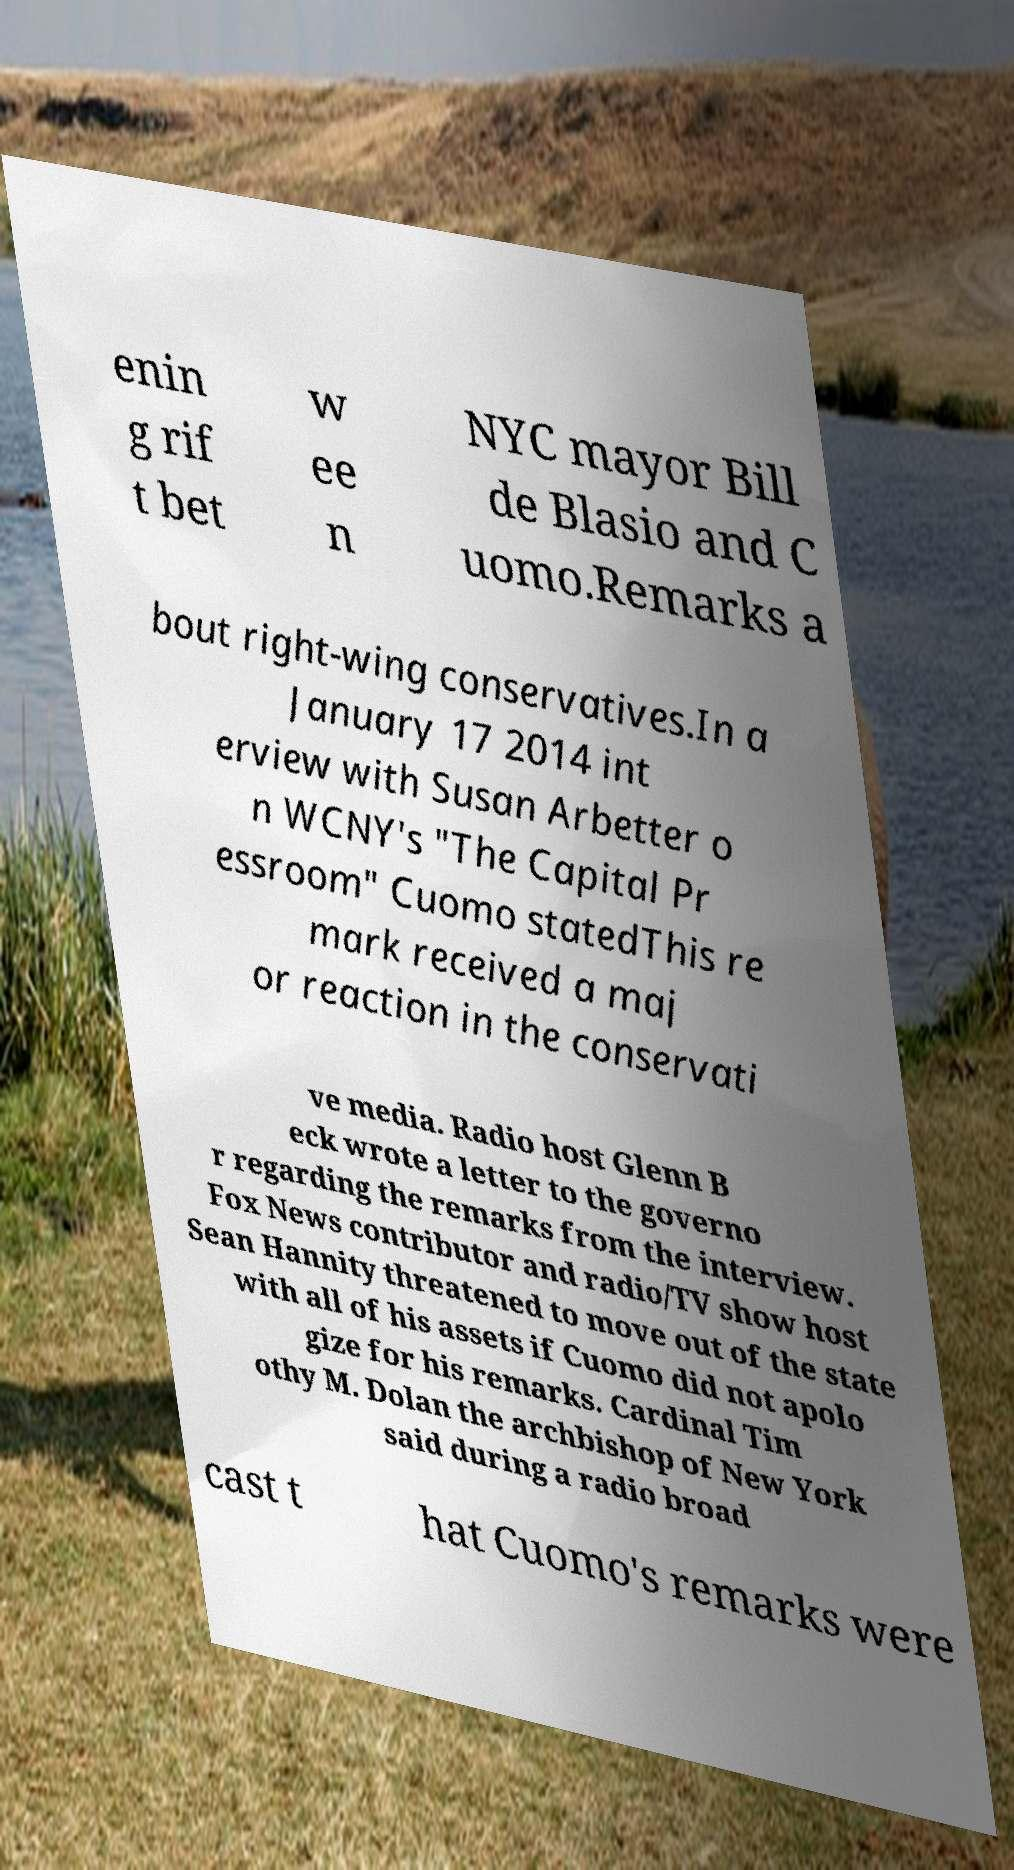For documentation purposes, I need the text within this image transcribed. Could you provide that? enin g rif t bet w ee n NYC mayor Bill de Blasio and C uomo.Remarks a bout right-wing conservatives.In a January 17 2014 int erview with Susan Arbetter o n WCNY's "The Capital Pr essroom" Cuomo statedThis re mark received a maj or reaction in the conservati ve media. Radio host Glenn B eck wrote a letter to the governo r regarding the remarks from the interview. Fox News contributor and radio/TV show host Sean Hannity threatened to move out of the state with all of his assets if Cuomo did not apolo gize for his remarks. Cardinal Tim othy M. Dolan the archbishop of New York said during a radio broad cast t hat Cuomo's remarks were 